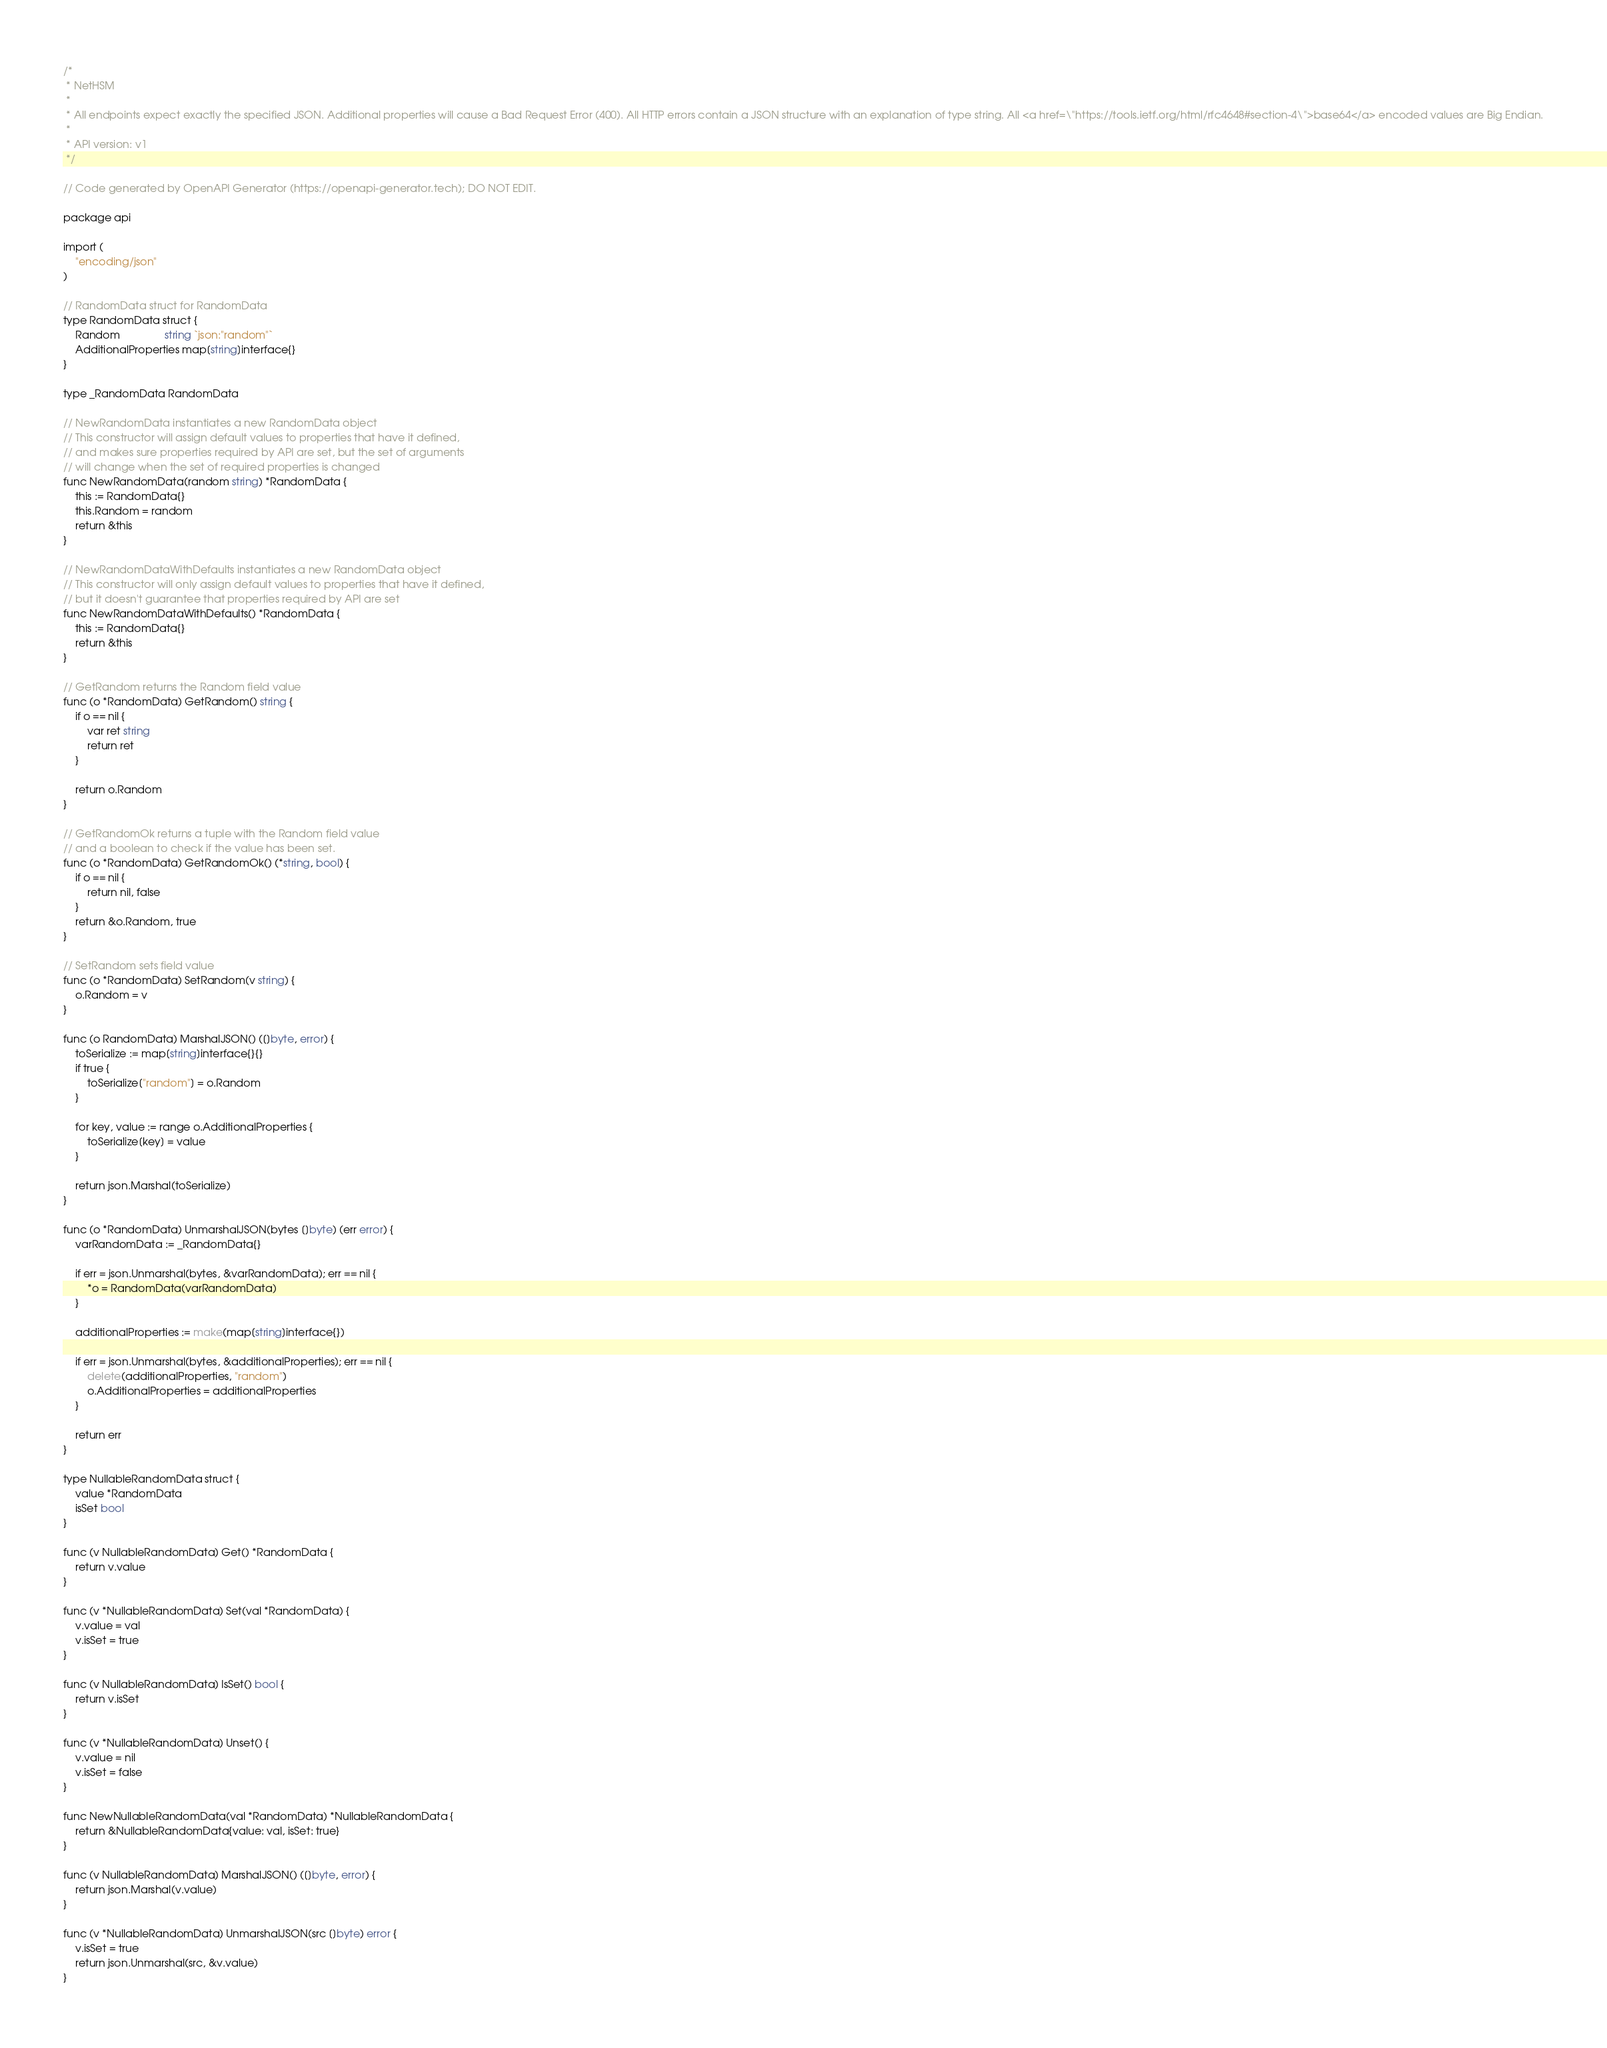Convert code to text. <code><loc_0><loc_0><loc_500><loc_500><_Go_>/*
 * NetHSM
 *
 * All endpoints expect exactly the specified JSON. Additional properties will cause a Bad Request Error (400). All HTTP errors contain a JSON structure with an explanation of type string. All <a href=\"https://tools.ietf.org/html/rfc4648#section-4\">base64</a> encoded values are Big Endian.
 *
 * API version: v1
 */

// Code generated by OpenAPI Generator (https://openapi-generator.tech); DO NOT EDIT.

package api

import (
	"encoding/json"
)

// RandomData struct for RandomData
type RandomData struct {
	Random               string `json:"random"`
	AdditionalProperties map[string]interface{}
}

type _RandomData RandomData

// NewRandomData instantiates a new RandomData object
// This constructor will assign default values to properties that have it defined,
// and makes sure properties required by API are set, but the set of arguments
// will change when the set of required properties is changed
func NewRandomData(random string) *RandomData {
	this := RandomData{}
	this.Random = random
	return &this
}

// NewRandomDataWithDefaults instantiates a new RandomData object
// This constructor will only assign default values to properties that have it defined,
// but it doesn't guarantee that properties required by API are set
func NewRandomDataWithDefaults() *RandomData {
	this := RandomData{}
	return &this
}

// GetRandom returns the Random field value
func (o *RandomData) GetRandom() string {
	if o == nil {
		var ret string
		return ret
	}

	return o.Random
}

// GetRandomOk returns a tuple with the Random field value
// and a boolean to check if the value has been set.
func (o *RandomData) GetRandomOk() (*string, bool) {
	if o == nil {
		return nil, false
	}
	return &o.Random, true
}

// SetRandom sets field value
func (o *RandomData) SetRandom(v string) {
	o.Random = v
}

func (o RandomData) MarshalJSON() ([]byte, error) {
	toSerialize := map[string]interface{}{}
	if true {
		toSerialize["random"] = o.Random
	}

	for key, value := range o.AdditionalProperties {
		toSerialize[key] = value
	}

	return json.Marshal(toSerialize)
}

func (o *RandomData) UnmarshalJSON(bytes []byte) (err error) {
	varRandomData := _RandomData{}

	if err = json.Unmarshal(bytes, &varRandomData); err == nil {
		*o = RandomData(varRandomData)
	}

	additionalProperties := make(map[string]interface{})

	if err = json.Unmarshal(bytes, &additionalProperties); err == nil {
		delete(additionalProperties, "random")
		o.AdditionalProperties = additionalProperties
	}

	return err
}

type NullableRandomData struct {
	value *RandomData
	isSet bool
}

func (v NullableRandomData) Get() *RandomData {
	return v.value
}

func (v *NullableRandomData) Set(val *RandomData) {
	v.value = val
	v.isSet = true
}

func (v NullableRandomData) IsSet() bool {
	return v.isSet
}

func (v *NullableRandomData) Unset() {
	v.value = nil
	v.isSet = false
}

func NewNullableRandomData(val *RandomData) *NullableRandomData {
	return &NullableRandomData{value: val, isSet: true}
}

func (v NullableRandomData) MarshalJSON() ([]byte, error) {
	return json.Marshal(v.value)
}

func (v *NullableRandomData) UnmarshalJSON(src []byte) error {
	v.isSet = true
	return json.Unmarshal(src, &v.value)
}
</code> 